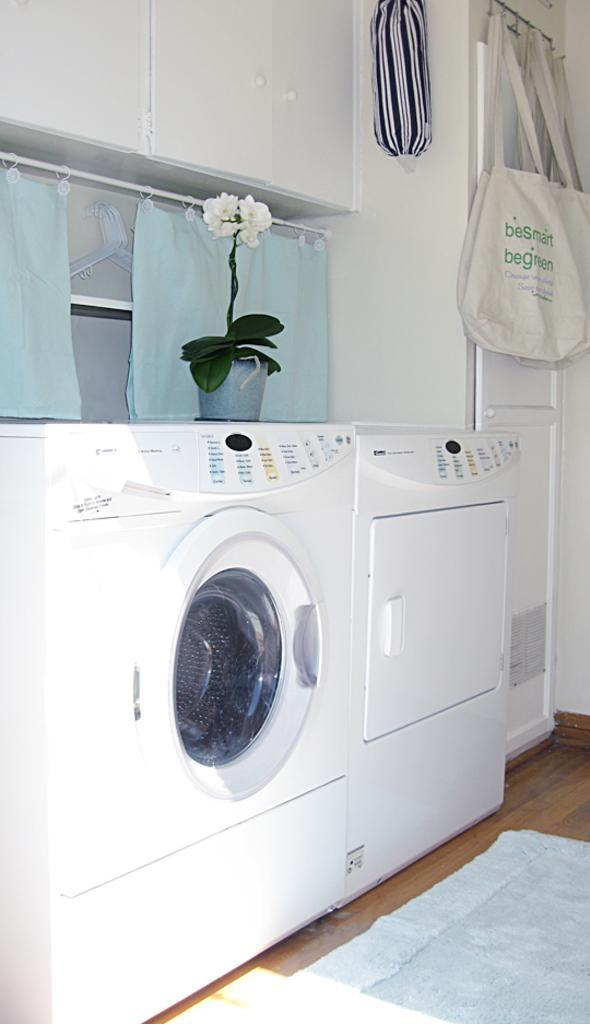Could you give a brief overview of what you see in this image? In this image we can see a washing machine. There are few carry bags hanged to a hanger. There is a house plant in the image. There is a mat on the floor. 